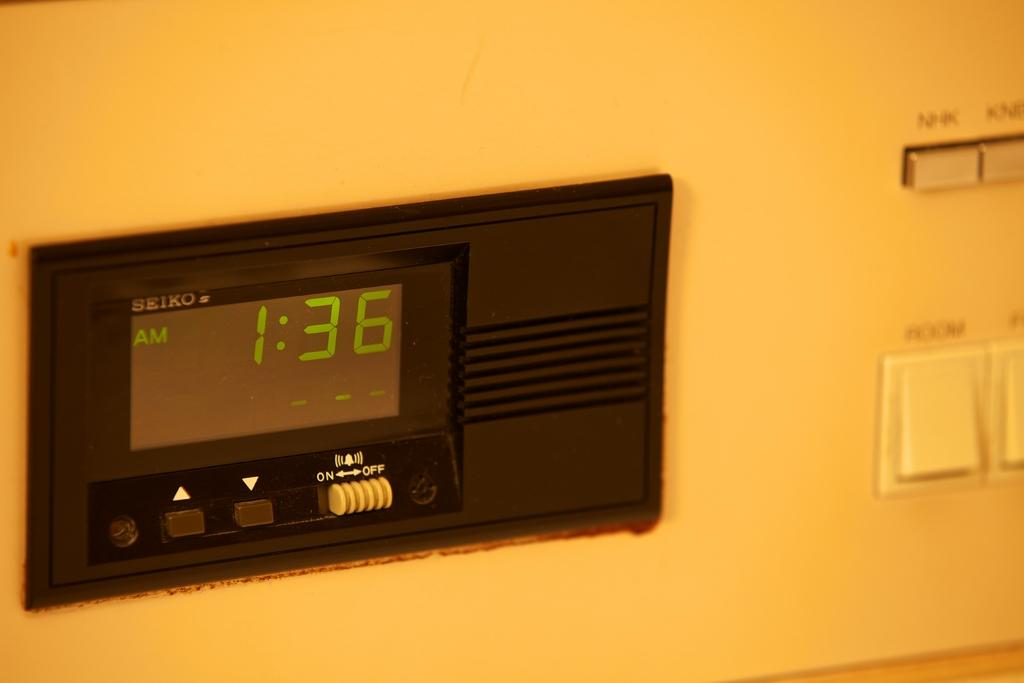<image>
Summarize the visual content of the image. a digital clock that says it is 1:36 am 